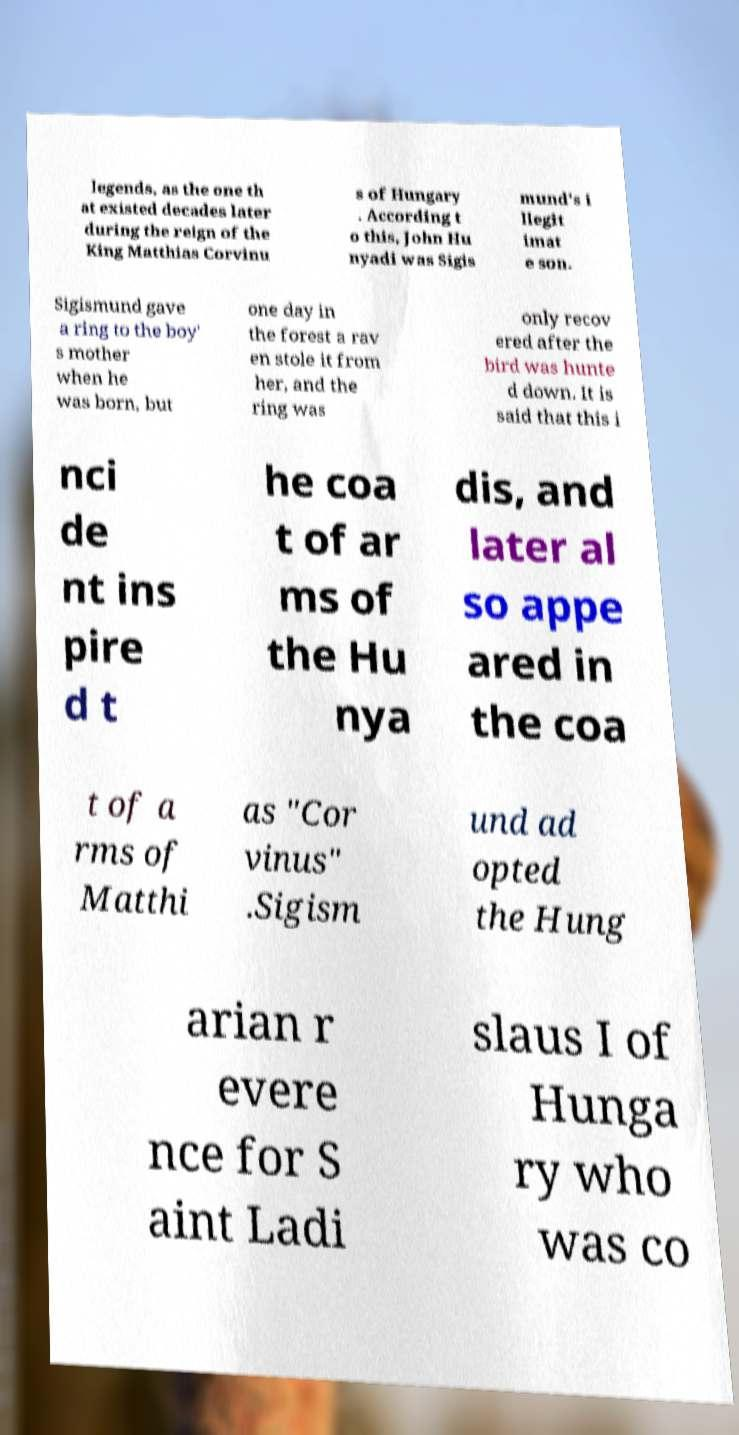Can you read and provide the text displayed in the image?This photo seems to have some interesting text. Can you extract and type it out for me? legends, as the one th at existed decades later during the reign of the King Matthias Corvinu s of Hungary . According t o this, John Hu nyadi was Sigis mund's i llegit imat e son. Sigismund gave a ring to the boy' s mother when he was born, but one day in the forest a rav en stole it from her, and the ring was only recov ered after the bird was hunte d down. It is said that this i nci de nt ins pire d t he coa t of ar ms of the Hu nya dis, and later al so appe ared in the coa t of a rms of Matthi as "Cor vinus" .Sigism und ad opted the Hung arian r evere nce for S aint Ladi slaus I of Hunga ry who was co 